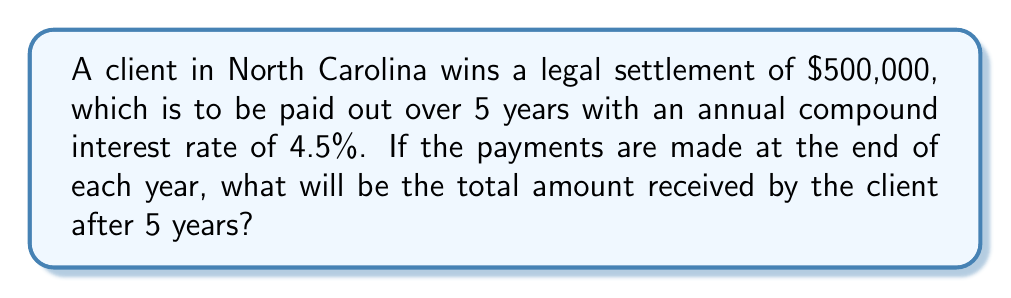Can you answer this question? To solve this problem, we'll use the compound interest formula:

$$A = P(1 + r)^n$$

Where:
$A$ = Final amount
$P$ = Principal (initial investment)
$r$ = Annual interest rate (as a decimal)
$n$ = Number of years

Given:
$P = 500,000$
$r = 0.045$ (4.5% converted to decimal)
$n = 5$ years

Step 1: Plug the values into the formula
$$A = 500,000(1 + 0.045)^5$$

Step 2: Calculate the expression inside the parentheses
$$A = 500,000(1.045)^5$$

Step 3: Calculate the exponent
$$A = 500,000(1.2462)$$

Step 4: Multiply
$$A = 623,100$$

Therefore, the total amount received by the client after 5 years will be $623,100.
Answer: $623,100 